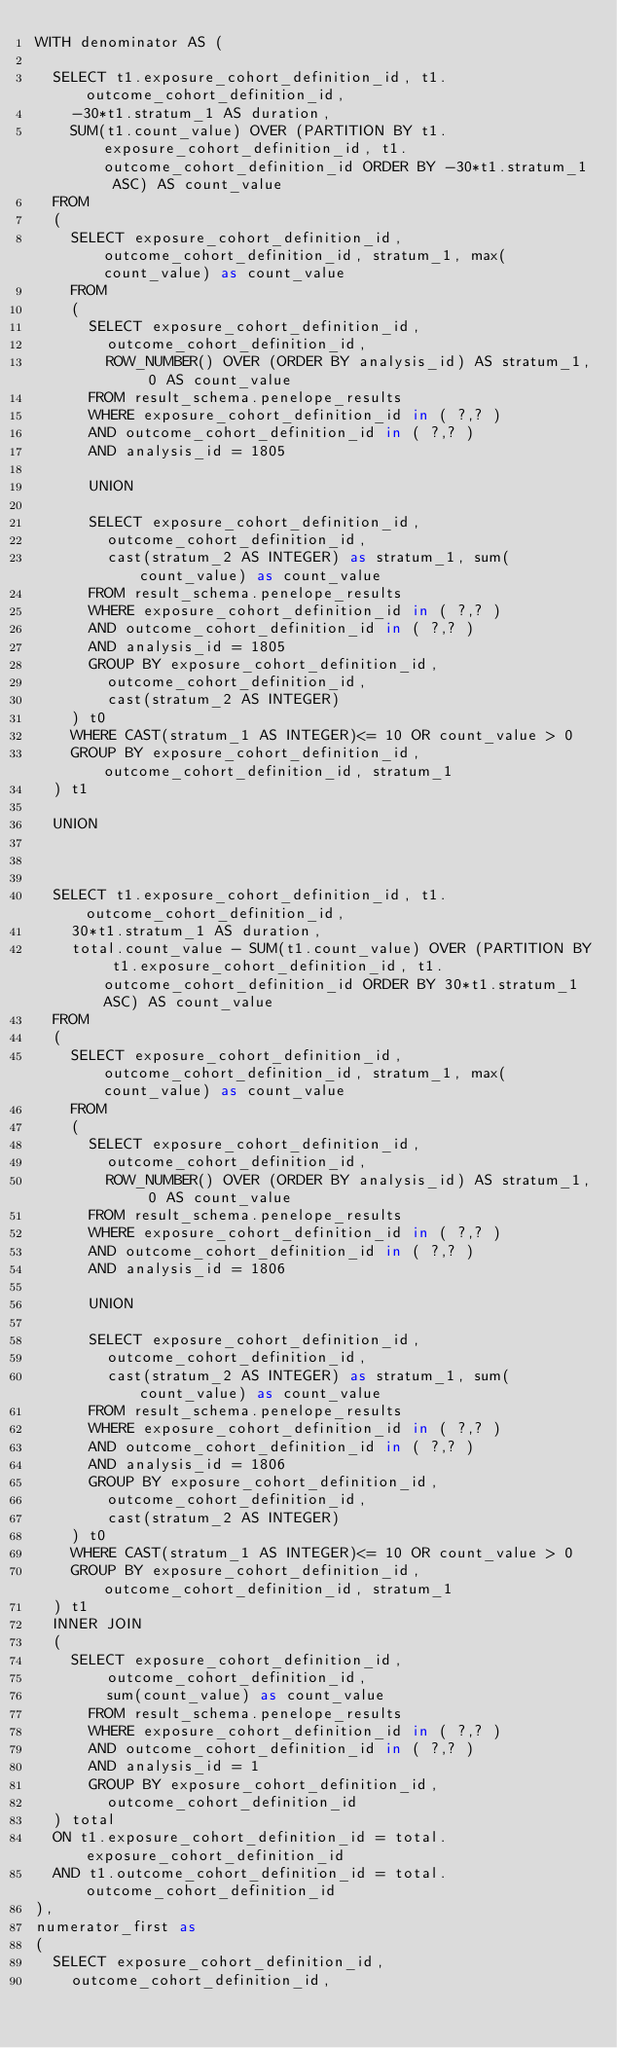<code> <loc_0><loc_0><loc_500><loc_500><_SQL_>WITH denominator AS (
	
	SELECT t1.exposure_cohort_definition_id, t1.outcome_cohort_definition_id,
		-30*t1.stratum_1 AS duration,
		SUM(t1.count_value) OVER (PARTITION BY t1.exposure_cohort_definition_id, t1.outcome_cohort_definition_id ORDER BY -30*t1.stratum_1 ASC) AS count_value
	FROM
	(
		SELECT exposure_cohort_definition_id, outcome_cohort_definition_id, stratum_1, max(count_value) as count_value
		FROM
		(
			SELECT exposure_cohort_definition_id, 
				outcome_cohort_definition_id,
				ROW_NUMBER() OVER (ORDER BY analysis_id) AS stratum_1, 0 AS count_value
			FROM result_schema.penelope_results
			WHERE exposure_cohort_definition_id in ( ?,? )
			AND outcome_cohort_definition_id in ( ?,? )
			AND analysis_id = 1805

			UNION

			SELECT exposure_cohort_definition_id, 
				outcome_cohort_definition_id,
				cast(stratum_2 AS INTEGER) as stratum_1, sum(count_value) as count_value
			FROM result_schema.penelope_results
			WHERE exposure_cohort_definition_id in ( ?,? )
			AND outcome_cohort_definition_id in ( ?,? )
			AND analysis_id = 1805
			GROUP BY exposure_cohort_definition_id, 
				outcome_cohort_definition_id,
				cast(stratum_2 AS INTEGER)
		) t0
		WHERE CAST(stratum_1 AS INTEGER)<= 10 OR count_value > 0
		GROUP BY exposure_cohort_definition_id, outcome_cohort_definition_id, stratum_1 
	) t1

	UNION

	

	SELECT t1.exposure_cohort_definition_id, t1.outcome_cohort_definition_id,
		30*t1.stratum_1 AS duration,
		total.count_value - SUM(t1.count_value) OVER (PARTITION BY t1.exposure_cohort_definition_id, t1.outcome_cohort_definition_id ORDER BY 30*t1.stratum_1 ASC) AS count_value
	FROM
	(
		SELECT exposure_cohort_definition_id, outcome_cohort_definition_id, stratum_1, max(count_value) as count_value
		FROM
		(
			SELECT exposure_cohort_definition_id, 
				outcome_cohort_definition_id,
				ROW_NUMBER() OVER (ORDER BY analysis_id) AS stratum_1, 0 AS count_value
			FROM result_schema.penelope_results
			WHERE exposure_cohort_definition_id in ( ?,? )
			AND outcome_cohort_definition_id in ( ?,? )
			AND analysis_id = 1806

			UNION

			SELECT exposure_cohort_definition_id, 
				outcome_cohort_definition_id,
				cast(stratum_2 AS INTEGER) as stratum_1, sum(count_value) as count_value
			FROM result_schema.penelope_results
			WHERE exposure_cohort_definition_id in ( ?,? )
			AND outcome_cohort_definition_id in ( ?,? )
			AND analysis_id = 1806
			GROUP BY exposure_cohort_definition_id, 
				outcome_cohort_definition_id,
				cast(stratum_2 AS INTEGER)
		) t0
		WHERE CAST(stratum_1 AS INTEGER)<= 10 OR count_value > 0
		GROUP BY exposure_cohort_definition_id, outcome_cohort_definition_id, stratum_1 
	) t1
	INNER JOIN
	(
		SELECT exposure_cohort_definition_id, 
				outcome_cohort_definition_id,
				sum(count_value) as count_value
			FROM result_schema.penelope_results
			WHERE exposure_cohort_definition_id in ( ?,? )
			AND outcome_cohort_definition_id in ( ?,? )
			AND analysis_id = 1
			GROUP BY exposure_cohort_definition_id, 
				outcome_cohort_definition_id
	) total
	ON t1.exposure_cohort_definition_id = total.exposure_cohort_definition_id
	AND t1.outcome_cohort_definition_id = total.outcome_cohort_definition_id
),
numerator_first as
(
	SELECT exposure_cohort_definition_id, 
		outcome_cohort_definition_id,</code> 